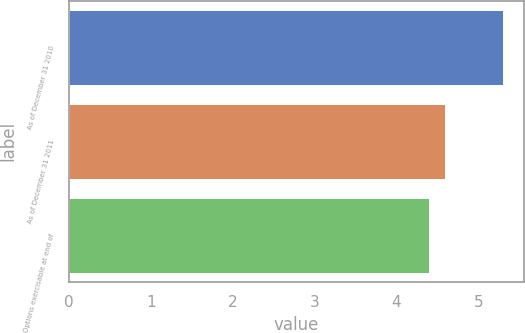Convert chart to OTSL. <chart><loc_0><loc_0><loc_500><loc_500><bar_chart><fcel>As of December 31 2010<fcel>As of December 31 2011<fcel>Options exercisable at end of<nl><fcel>5.3<fcel>4.6<fcel>4.4<nl></chart> 